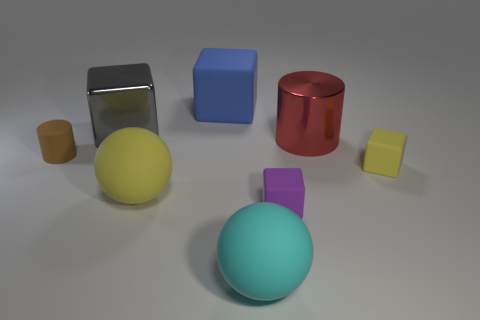Subtract all tiny purple rubber cubes. How many cubes are left? 3 Subtract all blue blocks. How many blocks are left? 3 Subtract 0 blue cylinders. How many objects are left? 8 Subtract all spheres. How many objects are left? 6 Subtract all red blocks. Subtract all brown balls. How many blocks are left? 4 Subtract all purple spheres. How many blue blocks are left? 1 Subtract all big purple matte spheres. Subtract all small yellow matte things. How many objects are left? 7 Add 8 yellow rubber objects. How many yellow rubber objects are left? 10 Add 1 big green cylinders. How many big green cylinders exist? 1 Add 2 tiny brown shiny blocks. How many objects exist? 10 